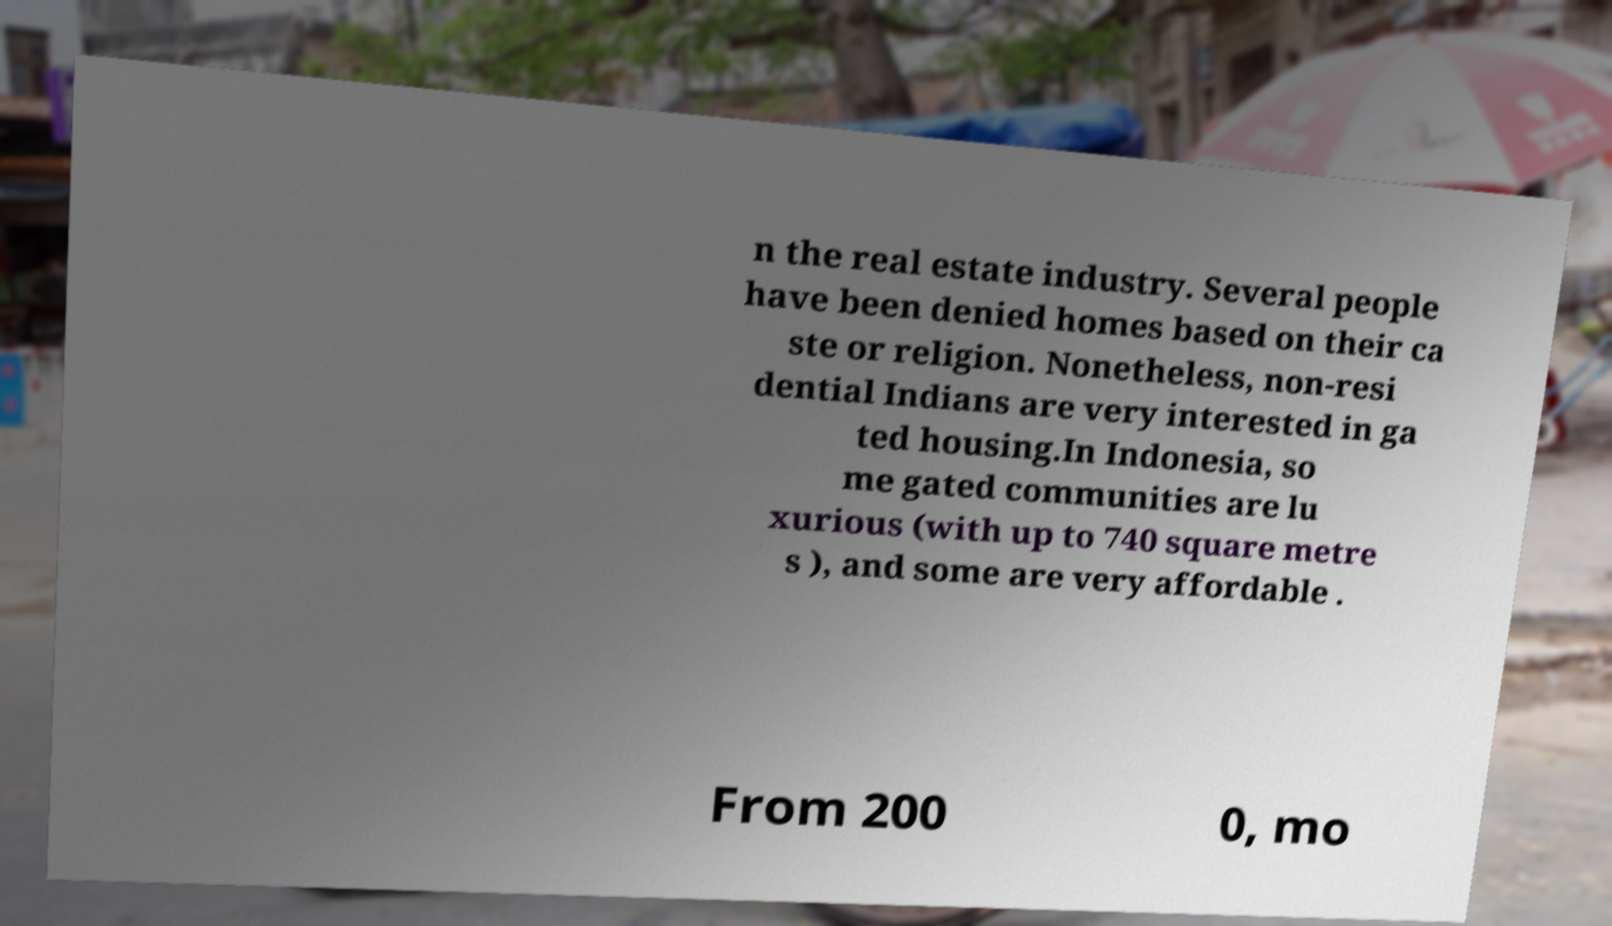Please read and relay the text visible in this image. What does it say? n the real estate industry. Several people have been denied homes based on their ca ste or religion. Nonetheless, non-resi dential Indians are very interested in ga ted housing.In Indonesia, so me gated communities are lu xurious (with up to 740 square metre s ), and some are very affordable . From 200 0, mo 